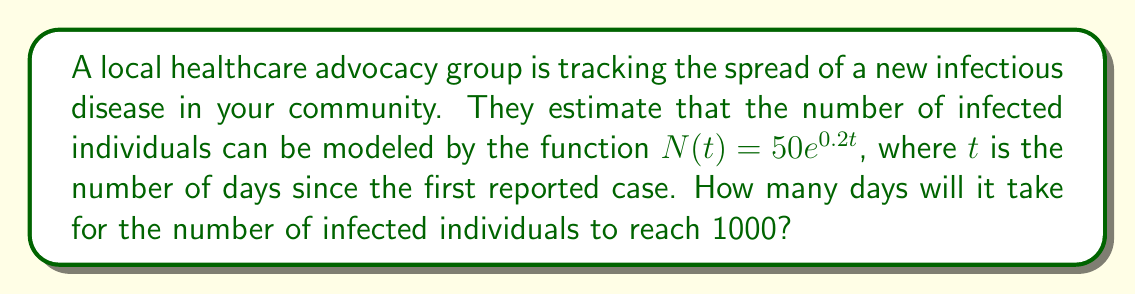Provide a solution to this math problem. To solve this problem, we need to use the given exponential function and solve for $t$ when $N(t) = 1000$. Let's break it down step-by-step:

1) We start with the equation: $N(t) = 50e^{0.2t}$

2) We want to find $t$ when $N(t) = 1000$, so we set up the equation:
   $1000 = 50e^{0.2t}$

3) Divide both sides by 50:
   $20 = e^{0.2t}$

4) Take the natural logarithm of both sides:
   $\ln(20) = \ln(e^{0.2t})$

5) Simplify the right side using the property of logarithms:
   $\ln(20) = 0.2t$

6) Divide both sides by 0.2:
   $\frac{\ln(20)}{0.2} = t$

7) Calculate the value:
   $t \approx 14.98$

8) Since we're dealing with days, we need to round up to the nearest whole number:
   $t = 15$

Therefore, it will take 15 days for the number of infected individuals to reach 1000.
Answer: 15 days 